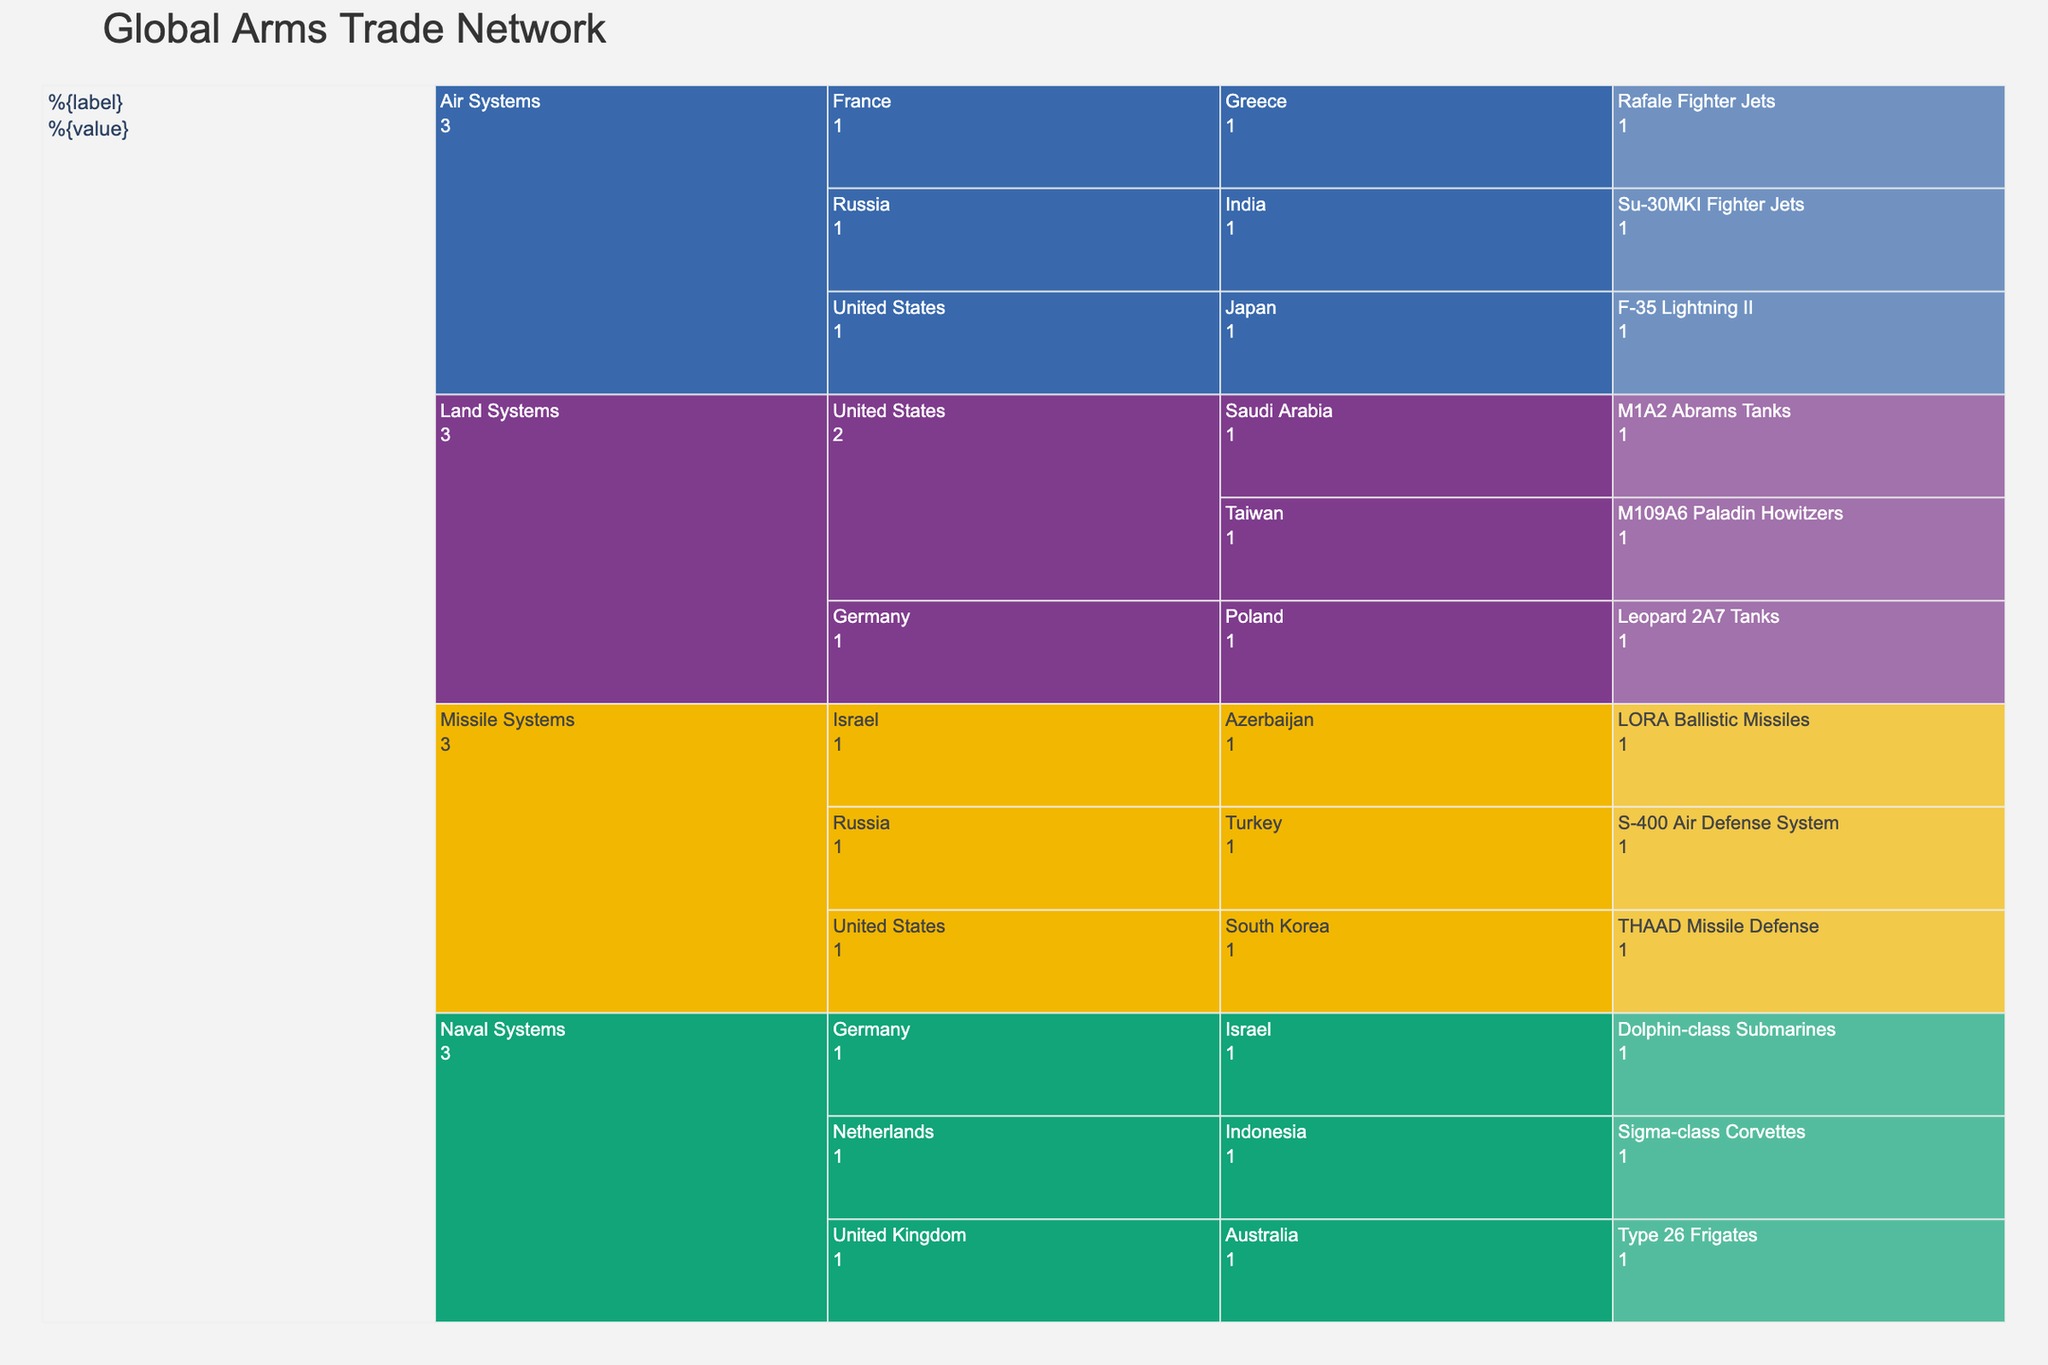What's the title of the figure? The title of the figure is typically displayed at the top of the chart. In this case, the title is "Global Arms Trade Network".
Answer: Global Arms Trade Network How many "Land Systems" Weapon Systems are there and who are the exporters? To find the number of "Land Systems" Weapon Systems, we look at the subplot under the "Land Systems" category. There are three Weapon Systems: M1A2 Abrams Tanks, M109A6 Paladin Howitzers, and Leopard 2A7 Tanks. The exporters for these are the United States and Germany.
Answer: 3, United States and Germany Which country exports the most diverse range of "Weapon Systems" and how do you know? To determine the country that exports the most diverse range of Weapon Systems, we look at the number of different weapon systems per exporter in the chart. In this case, the United States exports M1A2 Abrams Tanks (Land Systems), M109A6 Paladin Howitzers (Land Systems), F-35 Lightning II (Air Systems), and THAAD Missile Defense (Missile Systems). This is more diversity compared to other countries.
Answer: United States Who is the importer of the "Sigma-class Corvettes" and under which category does it fall? To identify the importer of the "Sigma-class Corvettes," we check the "Naval Systems" category, where we find that the importer is Indonesia.
Answer: Indonesia, Naval Systems Compare the number of Weapon Systems exported by the United States and Russia. Which has more? To compare the number of Weapon Systems exported by the United States and Russia, we count their respective exports. The United States exports four Weapon Systems while Russia exports three Weapon Systems. Therefore, the United States exports more.
Answer: United States Which category has the least exporters and how many are there? To find the category with the least exporters, we count the number of unique exporters in each category. Missile Systems has three exporters (Israel, United States, and Russia), whereas Land Systems and Naval Systems have three, and Air Systems has three. Therefore, the category with the least exporters is "Missile Systems" with three exporters.
Answer: Missile Systems, 3 Identify an instance where a country appears in both exporter and importer roles in different transactions. We need to find a country that is listed as both an exporter and an importer. Israel appears as an exporter for "LORA Ballistic Missiles" (Missile Systems) and as an importer for "Dolphin-class Submarines" (Naval Systems).
Answer: Israel If we combine all the Weapon Systems under "Air Systems," how many are there in total and what are their names? To determine the total number of Weapon Systems under "Air Systems," we count all the individual systems in that category: Su-30MKI Fighter Jets, Rafale Fighter Jets, and F-35 Lightning II. In total, there are three Weapon Systems under "Air Systems."
Answer: 3, Su-30MKI Fighter Jets, Rafale Fighter Jets, F-35 Lightning II Who are the exporters and importers involved in "Naval Systems"? To find the exporters and importers involved in "Naval Systems," we look at that category. The exporters are the United Kingdom, Germany, and Netherlands. The importers are Australia, Israel, and Indonesia, respectively.
Answer: United Kingdom, Germany, Netherlands; Australia, Israel, Indonesia 